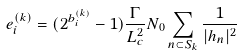Convert formula to latex. <formula><loc_0><loc_0><loc_500><loc_500>e _ { i } ^ { ( k ) } = ( 2 ^ { b _ { i } ^ { ( k ) } } - 1 ) \frac { \Gamma } { L _ { c } ^ { 2 } } N _ { 0 } \sum _ { n \subset S _ { k } } \frac { 1 } { | h _ { n } | ^ { 2 } }</formula> 